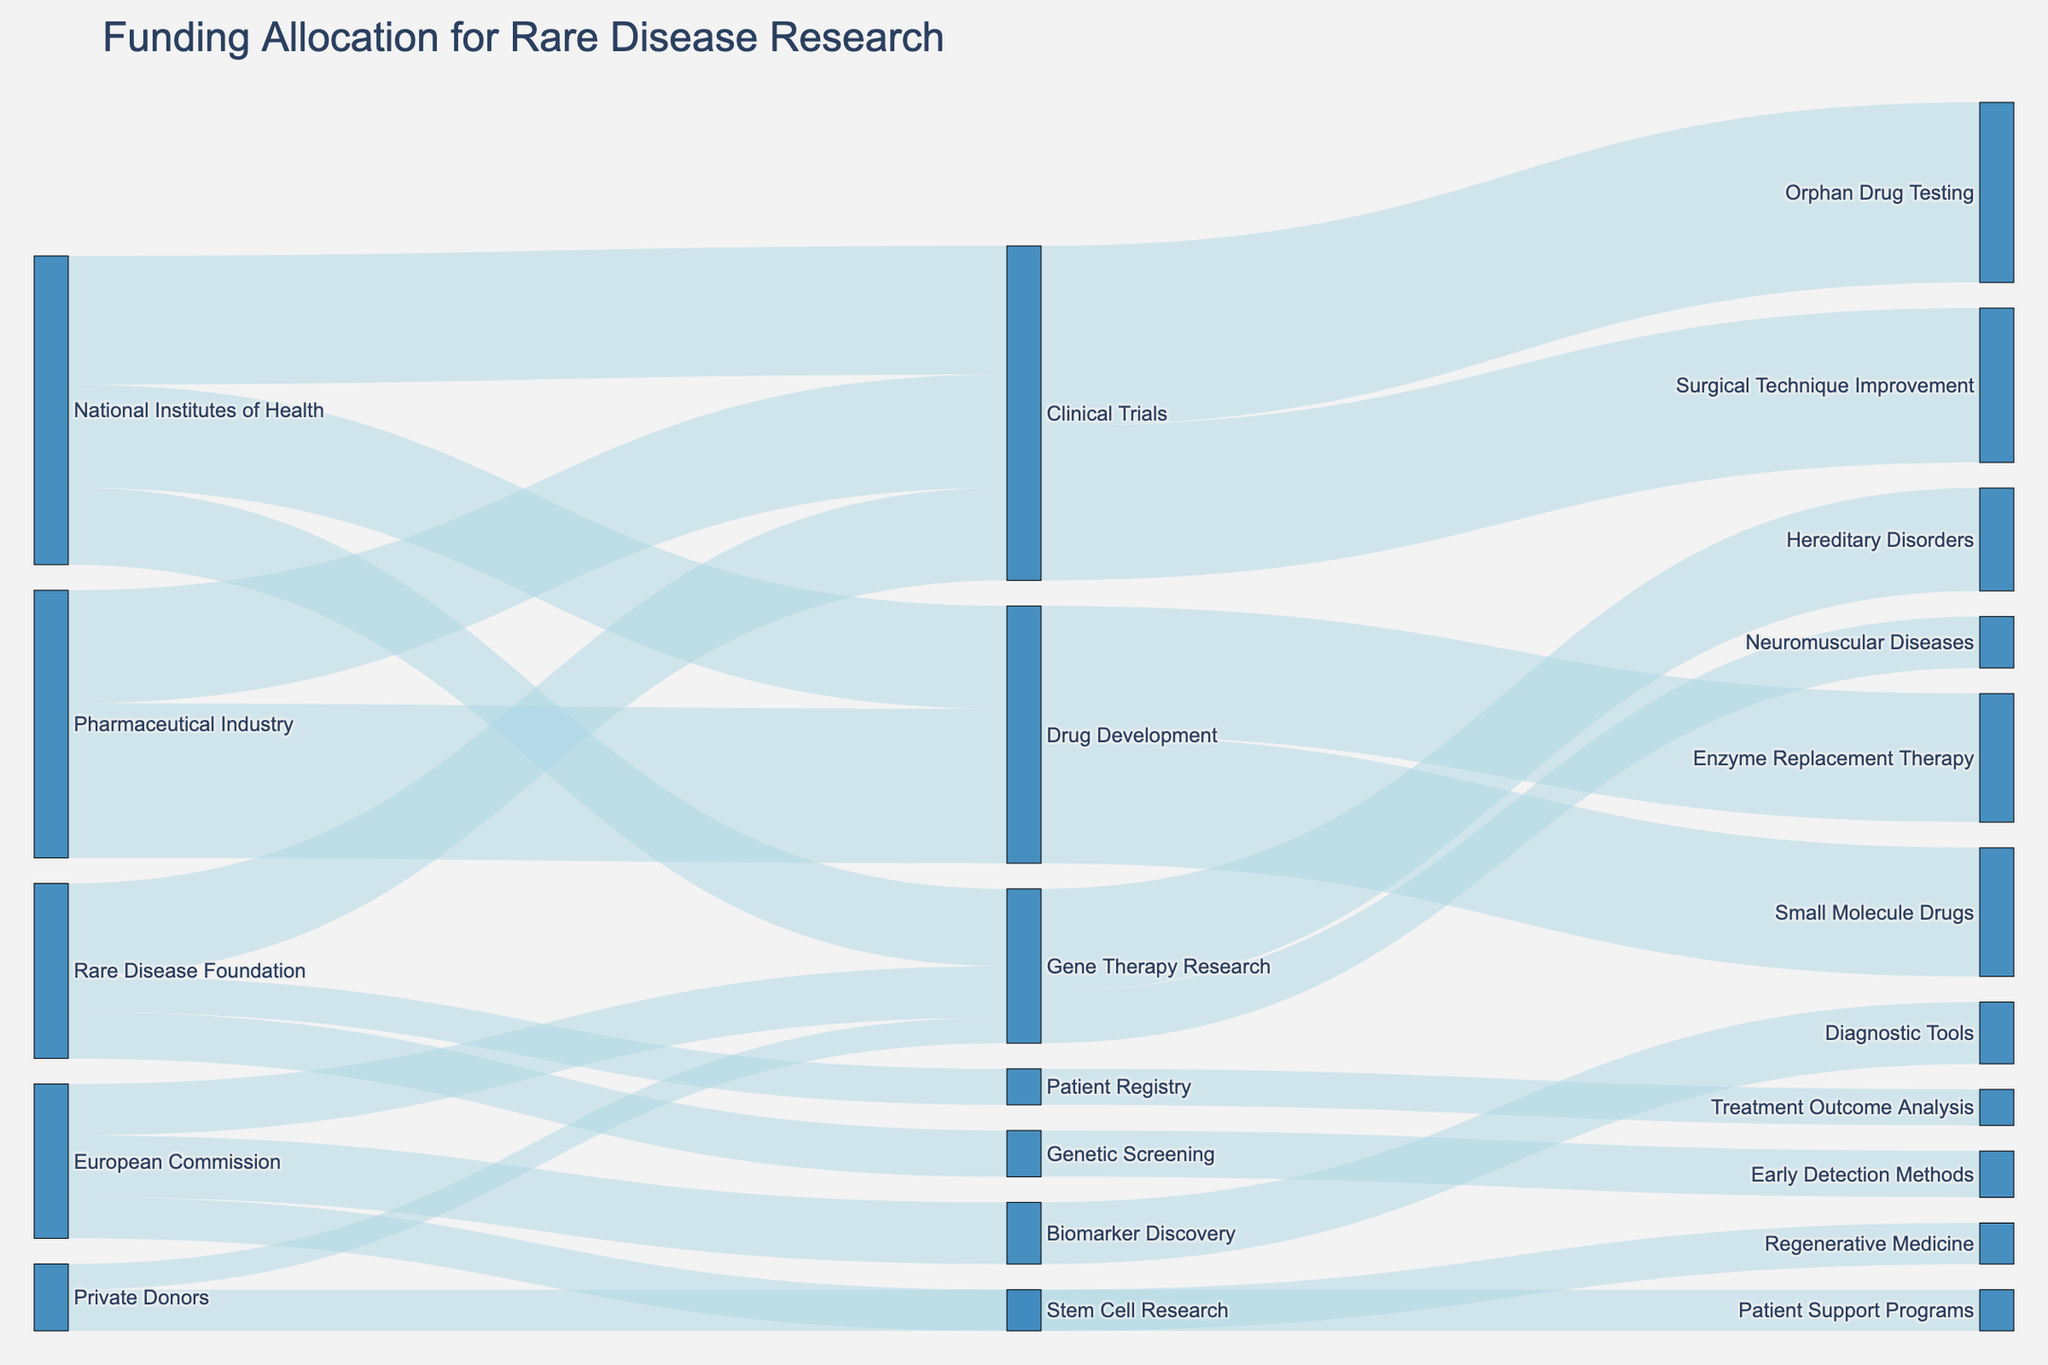What is the title of the diagram? The title is usually prominently displayed at the top of the figure. It provides a summary of what the figure represents.
Answer: Funding Allocation for Rare Disease Research How much funding did the National Institutes of Health allocate to Clinical Trials? Identify the link between "National Institutes of Health" and "Clinical Trials" and note the associated value.
Answer: 25 Which research area received the highest funding from the Pharmaceutical Industry? Look at the links originating from "Pharmaceutical Industry" and compare the values.
Answer: Drug Development Where did funding from Private Donors go? Check the target nodes linked from "Private Donors".
Answer: Gene Therapy Research, Patient Support Programs How much total funding was allocated to Patient Registry and Genetic Screening combined? Sum the funding values directed towards "Patient Registry" and "Genetic Screening".
Answer: 7 + 9 = 16 Compare the funding allocated to Gene Therapy Research from the National Institutes of Health and the European Commission. Which one is higher? Look at the values of the links from both sources to "Gene Therapy Research" and compare them.
Answer: National Institutes of Health What percentage of the funding allocated to Drug Development by the Pharmaceutical Industry went towards Enzyme Replacement Therapy? Find the value of funding for "Drug Development" from the "Pharmaceutical Industry" and the value directed towards "Enzyme Replacement Therapy" to calculate the percentage. (25/30) * 100 = 83.33%
Answer: 83.33% Which sources contributed to Clinical Trials and what are their respective amounts? Identify the sources linked to "Clinical Trials" and note their values.
Answer: National Institutes of Health: 25, Rare Disease Foundation: 18, Pharmaceutical Industry: 22 How much funding did Gene Therapy Research receive in total? Sum the funding values towards "Gene Therapy Research" from all sources.
Answer: 15 + 10 + 5 = 30 